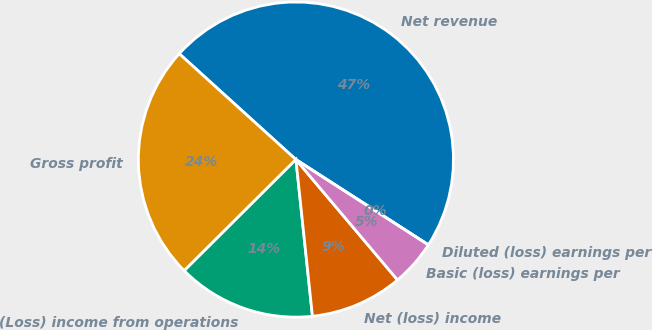<chart> <loc_0><loc_0><loc_500><loc_500><pie_chart><fcel>Net revenue<fcel>Gross profit<fcel>(Loss) income from operations<fcel>Net (loss) income<fcel>Basic (loss) earnings per<fcel>Diluted (loss) earnings per<nl><fcel>47.38%<fcel>24.19%<fcel>14.21%<fcel>9.48%<fcel>4.74%<fcel>0.0%<nl></chart> 